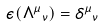Convert formula to latex. <formula><loc_0><loc_0><loc_500><loc_500>\epsilon ( { \Lambda ^ { \mu } } _ { \nu } ) = { \delta ^ { \mu } } _ { \nu }</formula> 